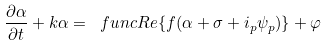<formula> <loc_0><loc_0><loc_500><loc_500>\frac { \partial \alpha } { \partial t } + k \alpha = \ f u n c { R e } \{ f ( \alpha + \sigma + i _ { p } \psi _ { p } ) \} + \varphi</formula> 